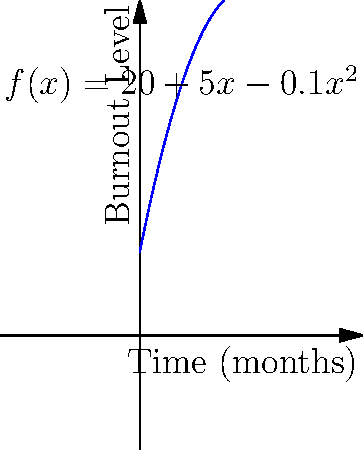In a tech company, employee burnout levels are modeled by the function $f(x) = 20 + 5x - 0.1x^2$, where $x$ represents the number of months since implementing a new project management system, and $f(x)$ represents the average burnout level on a scale of 0-100. At what point in time is the rate of change in burnout levels equal to zero, and what does this imply for the company's working conditions? To solve this problem, we need to follow these steps:

1) The rate of change in burnout levels is represented by the derivative of the function $f(x)$.

2) First, let's find the derivative:
   $f'(x) = 5 - 0.2x$

3) We want to find when the rate of change is zero, so we set $f'(x) = 0$:
   $5 - 0.2x = 0$

4) Solve for $x$:
   $-0.2x = -5$
   $x = 25$

5) This means that after 25 months, the rate of change in burnout levels will be zero.

6) To interpret this for the company:
   - Before 25 months, $f'(x)$ is positive, so burnout is increasing.
   - At 25 months, $f'(x) = 0$, so burnout reaches its peak.
   - After 25 months, $f'(x)$ becomes negative, so burnout starts decreasing.

This implies that the new project management system initially leads to increased burnout, but after 25 months, it starts to have a positive effect on reducing burnout levels.
Answer: 25 months; burnout peaks and starts decreasing afterwards. 